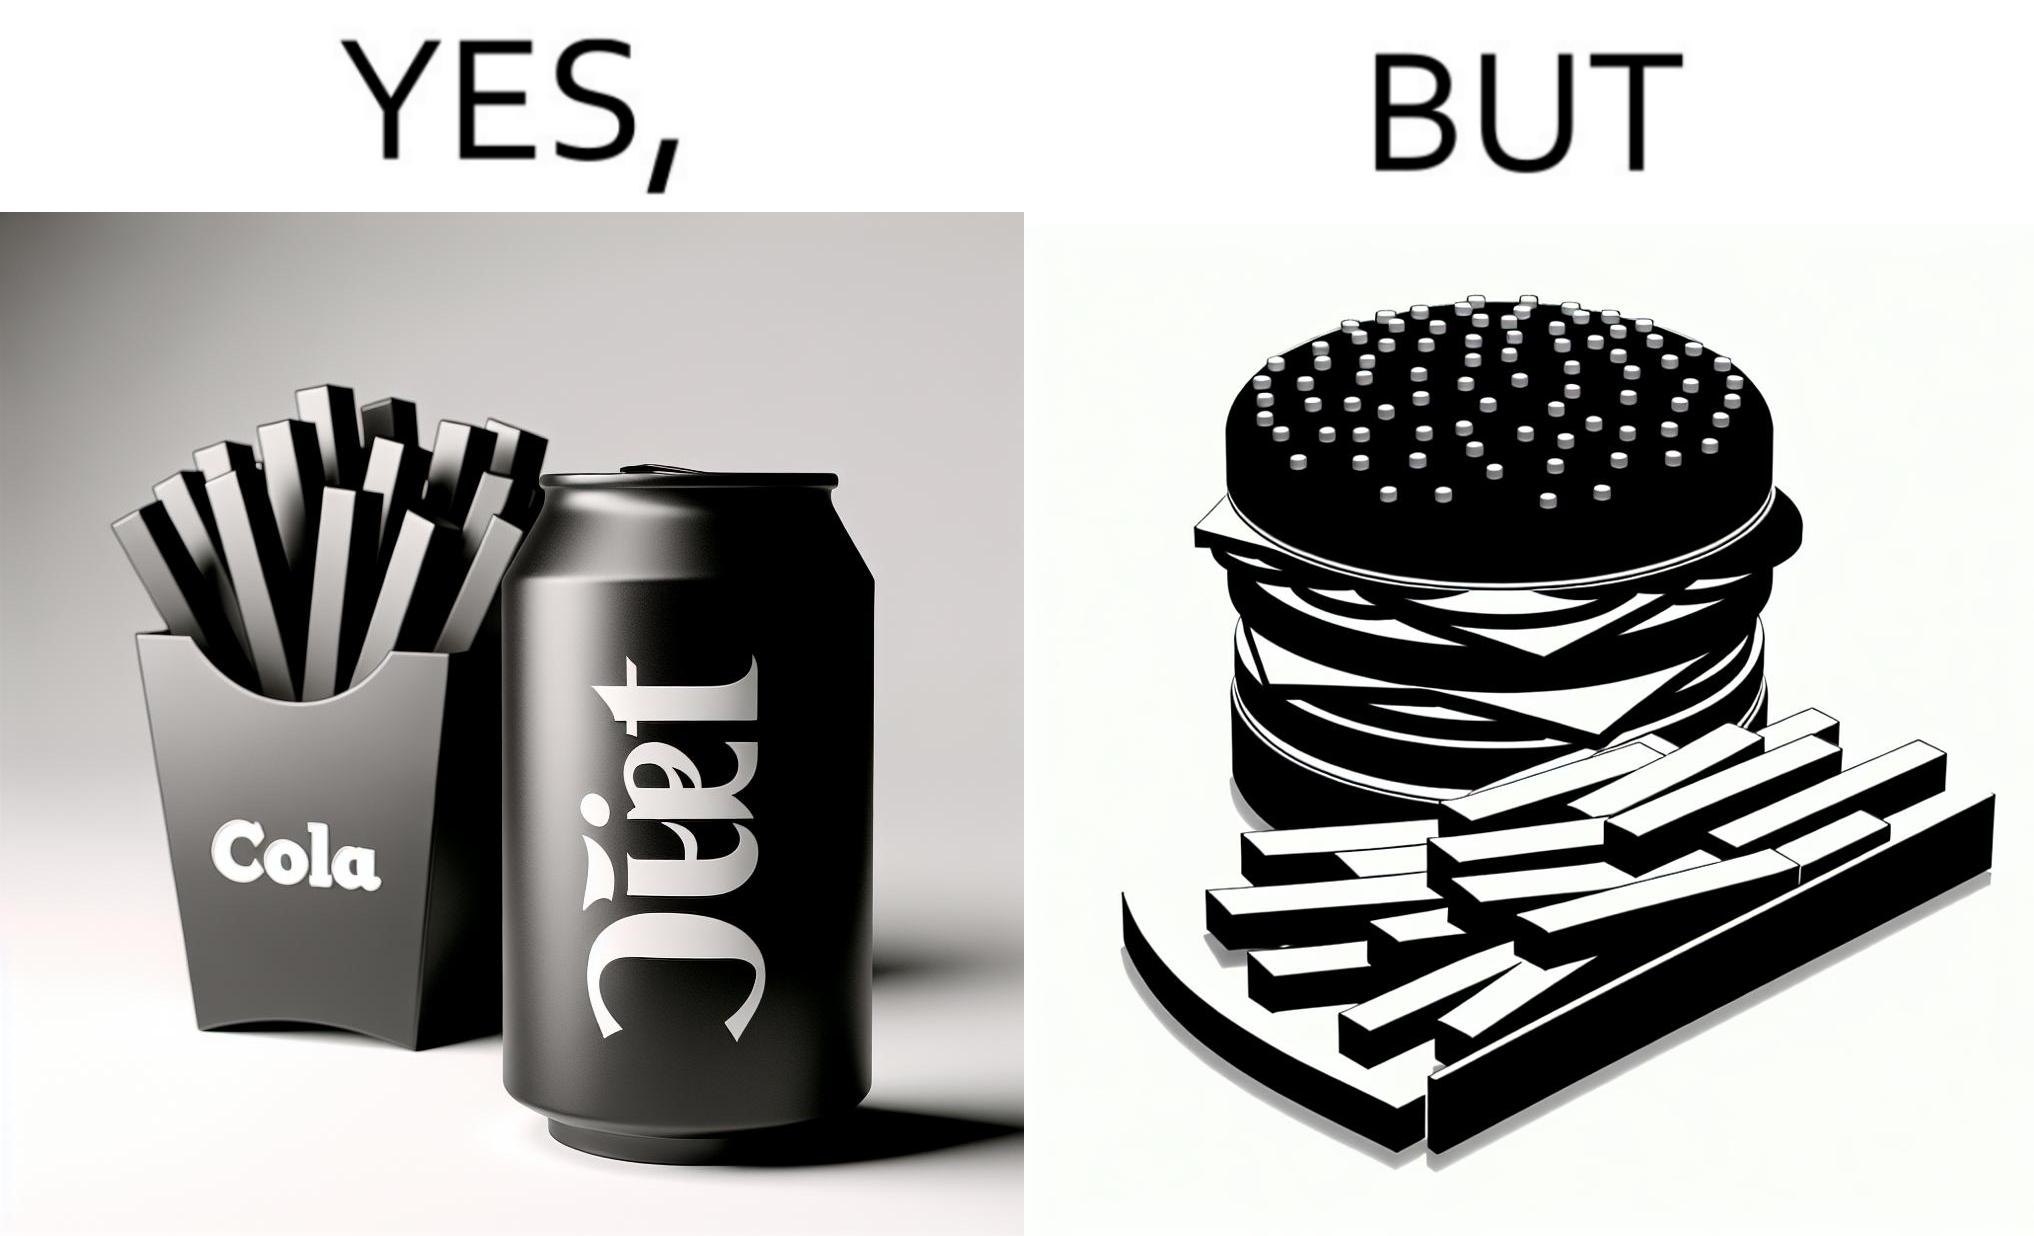What is shown in this image? The image is ironic, because on one hand the person is consuming diet cola suggesting low on sugar as per label meaning the person is health-conscious but on the other hand the same one is having huge size burger with french fries which suggests the person to be health-ignorant 